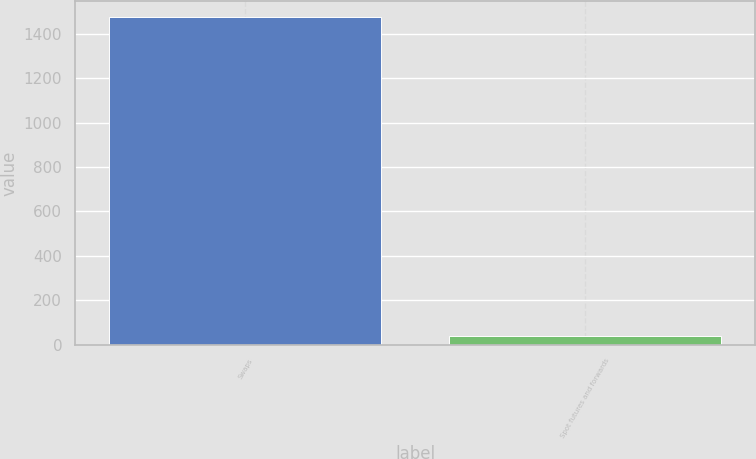<chart> <loc_0><loc_0><loc_500><loc_500><bar_chart><fcel>Swaps<fcel>Spot futures and forwards<nl><fcel>1473<fcel>39.2<nl></chart> 